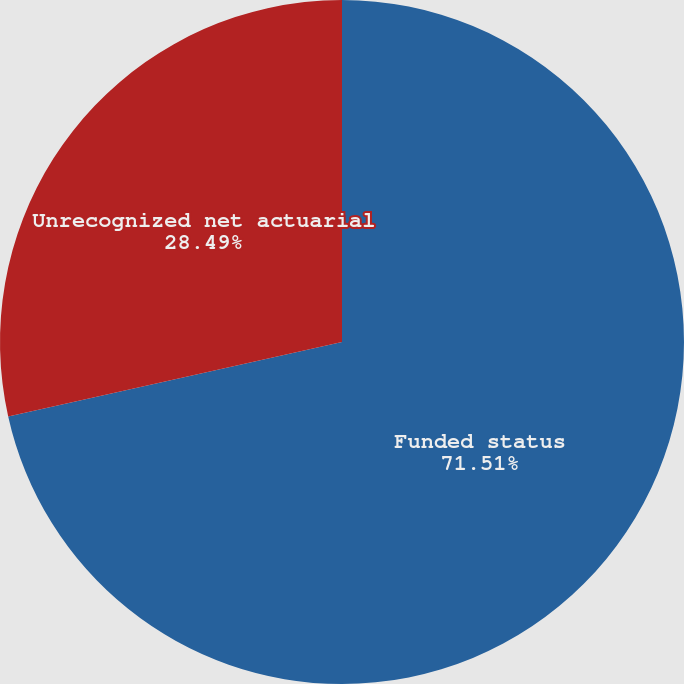<chart> <loc_0><loc_0><loc_500><loc_500><pie_chart><fcel>Funded status<fcel>Unrecognized net actuarial<nl><fcel>71.51%<fcel>28.49%<nl></chart> 